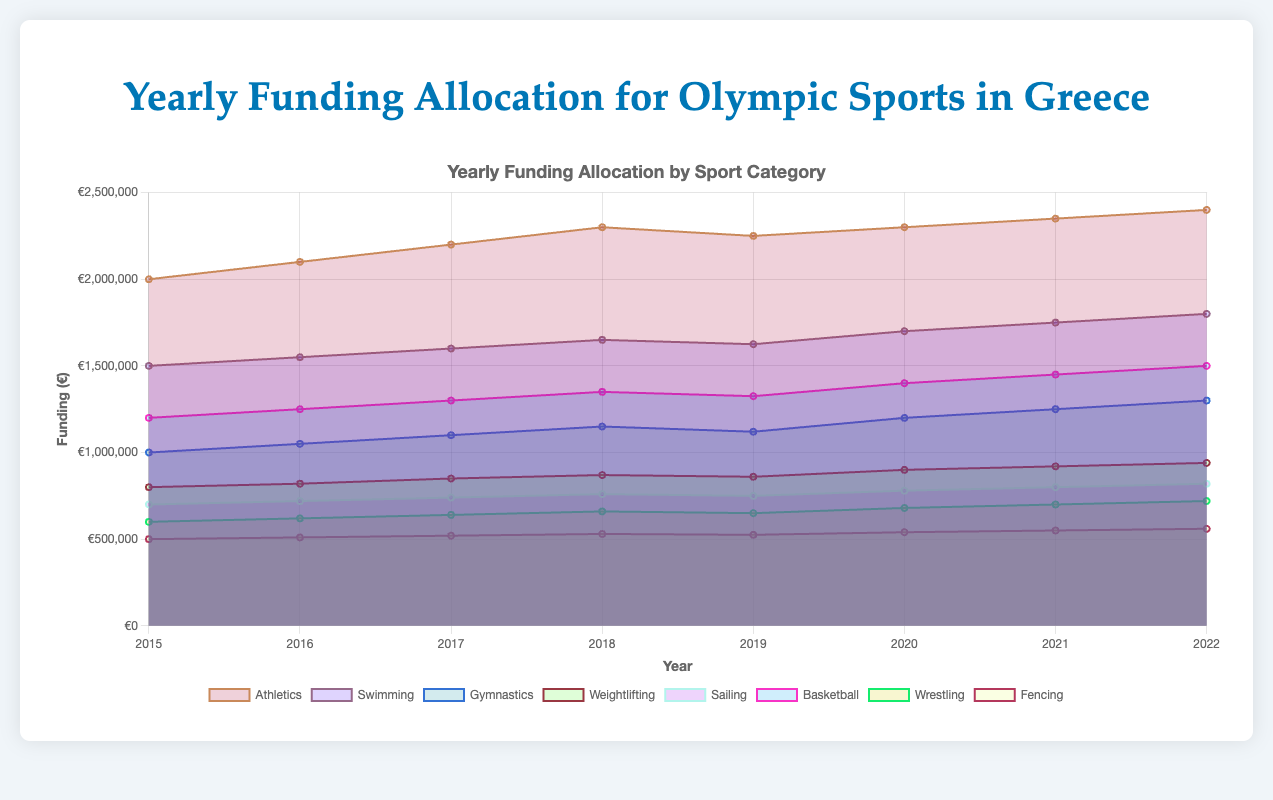What is the title of the chart? The title of the chart is displayed at the top, usually in a larger or bold font for emphasis, and it reads "Yearly Funding Allocation for Olympic Sports in Greece."
Answer: Yearly Funding Allocation for Olympic Sports in Greece What are the categories of sports included in the chart? To find the categories, look at the legend or labels attached to different colored areas of the chart. The categories listed in the chart include Athletics, Swimming, Gymnastics, Weightlifting, Sailing, Basketball, Wrestling, and Fencing.
Answer: Athletics, Swimming, Gymnastics, Weightlifting, Sailing, Basketball, Wrestling, Fencing What years are covered by the funding data in the chart? The x-axis typically represents the timeline. Here, the years listed at the bottom of the chart are 2015, 2016, 2017, 2018, 2019, 2020, 2021, and 2022.
Answer: 2015-2022 Which sport had the highest funding in 2022? Look at the height of each colored area representing different sports for the year 2022. The highest area in 2022 corresponds to Athletics.
Answer: Athletics What is the total funding across all sports in the year 2020? Sum up the funding amounts for each sport for the year 2020. These are: Athletics €2,300,000 + Swimming €1,700,000 + Gymnastics €1,200,000 + Weightlifting €900,000 + Sailing €780,000 + Basketball €1,400,000 + Wrestling €680,000 + Fencing €540,000. The total is €10,500,000.
Answer: €10,500,000 How did the funding for Basketball change from 2016 to 2021? Look at the height of the Basketball area in 2016 and compare it to 2021. In 2016, it was €1,250,000, and in 2021, it was €1,450,000. Calculate the change: €1,450,000 - €1,250,000 = €200,000.
Answer: Increased by €200,000 Which sport had the smallest increase in funding from 2015 to 2022? Look at the difference between the funding in 2015 and 2022 for each sport and identify the smallest increase. For Fencing, the increase is €560,000 - €500,000 = €60,000, which is the smallest amongst all sports.
Answer: Fencing In which year was the total funding the highest? Sum the funding for all sports for each year and compare the totals. The highest total is in 2022 at €10,900,000.
Answer: 2022 What is the trend in funding for Swimming over the years? Observe the height of the Swimming area across the years. From 2015 to 2022, the area steadily increases, showing a rising trend.
Answer: Increasing How does the funding for Gymnastics in 2018 compare to that in 2020? Look at the height of the Gymnastics area in 2018 and compare it to 2020. In 2018, it was €1,150,000, and in 2020, it was €1,200,000.
Answer: €50,000 increase 